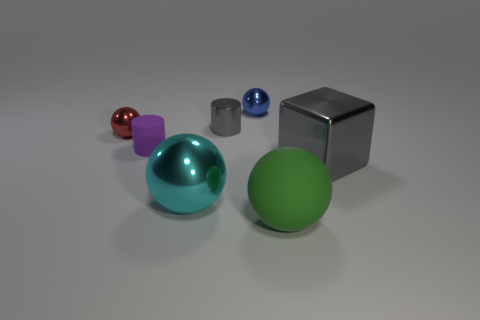Subtract all large green matte spheres. How many spheres are left? 3 Add 1 tiny red objects. How many objects exist? 8 Subtract all red balls. How many balls are left? 3 Subtract all cylinders. How many objects are left? 5 Subtract 1 spheres. How many spheres are left? 3 Subtract all large blue metallic cylinders. Subtract all tiny blue metal spheres. How many objects are left? 6 Add 6 blue balls. How many blue balls are left? 7 Add 4 gray metal cubes. How many gray metal cubes exist? 5 Subtract 0 cyan cylinders. How many objects are left? 7 Subtract all gray spheres. Subtract all red cubes. How many spheres are left? 4 